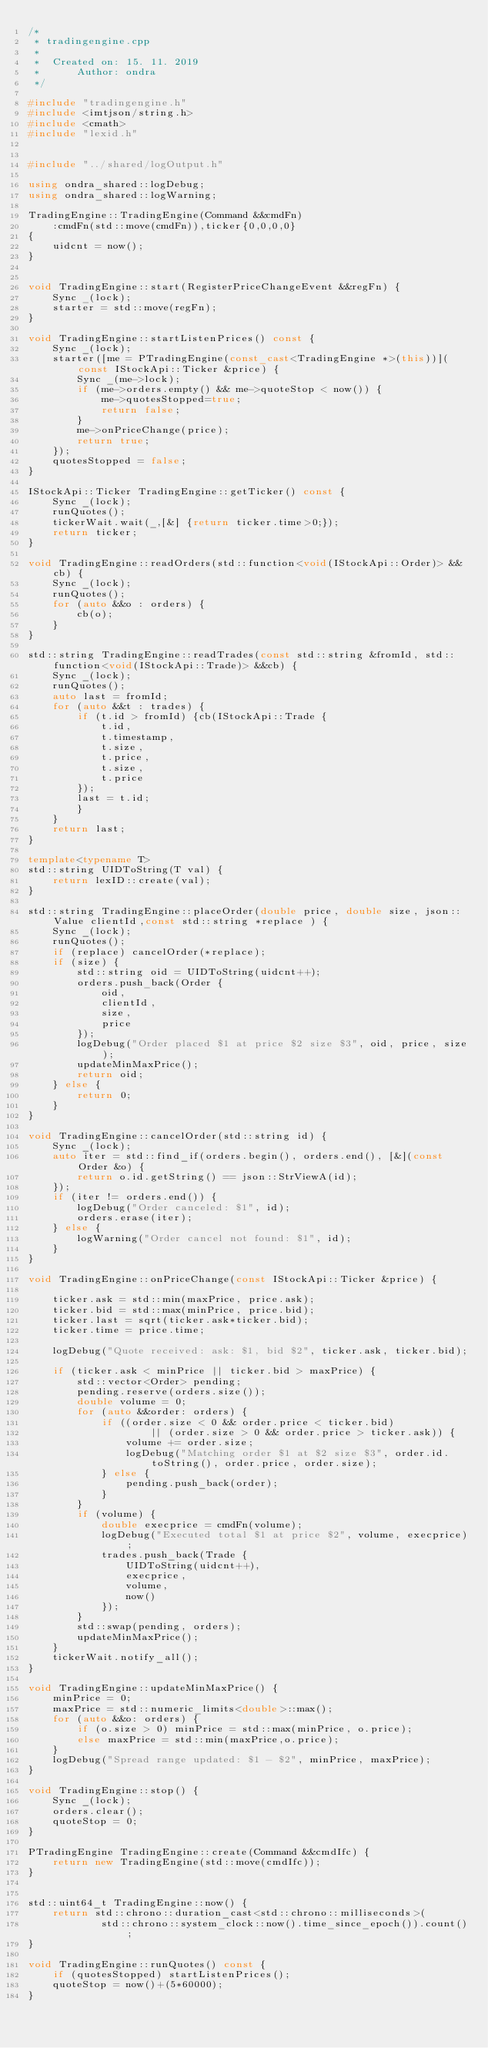<code> <loc_0><loc_0><loc_500><loc_500><_C++_>/*
 * tradingengine.cpp
 *
 *  Created on: 15. 11. 2019
 *      Author: ondra
 */

#include "tradingengine.h"
#include <imtjson/string.h>
#include <cmath>
#include "lexid.h"


#include "../shared/logOutput.h"

using ondra_shared::logDebug;
using ondra_shared::logWarning;

TradingEngine::TradingEngine(Command &&cmdFn)
	:cmdFn(std::move(cmdFn)),ticker{0,0,0,0}
{
	uidcnt = now();
}


void TradingEngine::start(RegisterPriceChangeEvent &&regFn) {
	Sync _(lock);
	starter = std::move(regFn);
}

void TradingEngine::startListenPrices() const {
	Sync _(lock);
	starter([me = PTradingEngine(const_cast<TradingEngine *>(this))](const IStockApi::Ticker &price) {
		Sync _(me->lock);
		if (me->orders.empty() && me->quoteStop < now()) {
			me->quotesStopped=true;
			return false;
		}
		me->onPriceChange(price);
		return true;
	});
	quotesStopped = false;
}

IStockApi::Ticker TradingEngine::getTicker() const {
	Sync _(lock);
	runQuotes();
	tickerWait.wait(_,[&] {return ticker.time>0;});
	return ticker;
}

void TradingEngine::readOrders(std::function<void(IStockApi::Order)> &&cb) {
	Sync _(lock);
	runQuotes();
	for (auto &&o : orders) {
		cb(o);
	}
}

std::string TradingEngine::readTrades(const std::string &fromId, std::function<void(IStockApi::Trade)> &&cb) {
	Sync _(lock);
	runQuotes();
	auto last = fromId;
	for (auto &&t : trades) {
		if (t.id > fromId) {cb(IStockApi::Trade {
			t.id,
			t.timestamp,
			t.size,
			t.price,
			t.size,
			t.price
		});
		last = t.id;
		}
	}
	return last;
}

template<typename T>
std::string UIDToString(T val) {
	return lexID::create(val);
}

std::string TradingEngine::placeOrder(double price, double size, json::Value clientId,const std::string *replace ) {
	Sync _(lock);
	runQuotes();
	if (replace) cancelOrder(*replace);
	if (size) {
		std::string oid = UIDToString(uidcnt++);
		orders.push_back(Order {
			oid,
			clientId,
			size,
			price
		});
		logDebug("Order placed $1 at price $2 size $3", oid, price, size);
		updateMinMaxPrice();
		return oid;
	} else {
		return 0;
	}
}

void TradingEngine::cancelOrder(std::string id) {
	Sync _(lock);
	auto iter = std::find_if(orders.begin(), orders.end(), [&](const Order &o) {
		return o.id.getString() == json::StrViewA(id);
	});
	if (iter != orders.end()) {
		logDebug("Order canceled: $1", id);
		orders.erase(iter);
	} else {
		logWarning("Order cancel not found: $1", id);
	}
}

void TradingEngine::onPriceChange(const IStockApi::Ticker &price) {

	ticker.ask = std::min(maxPrice, price.ask);
	ticker.bid = std::max(minPrice, price.bid);
	ticker.last = sqrt(ticker.ask*ticker.bid);
	ticker.time = price.time;

	logDebug("Quote received: ask: $1, bid $2", ticker.ask, ticker.bid);

	if (ticker.ask < minPrice || ticker.bid > maxPrice) {
		std::vector<Order> pending;
		pending.reserve(orders.size());
		double volume = 0;
		for (auto &&order: orders) {
			if ((order.size < 0 && order.price < ticker.bid)
					|| (order.size > 0 && order.price > ticker.ask)) {
				volume += order.size;
				logDebug("Matching order $1 at $2 size $3", order.id.toString(), order.price, order.size);
			} else {
				pending.push_back(order);
			}
		}
		if (volume) {
			double execprice = cmdFn(volume);
			logDebug("Executed total $1 at price $2", volume, execprice);
			trades.push_back(Trade {
				UIDToString(uidcnt++),
				execprice,
				volume,
				now()
			});
		}
		std::swap(pending, orders);
		updateMinMaxPrice();
	}
	tickerWait.notify_all();
}

void TradingEngine::updateMinMaxPrice() {
	minPrice = 0;
	maxPrice = std::numeric_limits<double>::max();
	for (auto &&o: orders) {
		if (o.size > 0) minPrice = std::max(minPrice, o.price);
		else maxPrice = std::min(maxPrice,o.price);
	}
	logDebug("Spread range updated: $1 - $2", minPrice, maxPrice);
}

void TradingEngine::stop() {
	Sync _(lock);
	orders.clear();
	quoteStop = 0;
}

PTradingEngine TradingEngine::create(Command &&cmdIfc) {
	return new TradingEngine(std::move(cmdIfc));
}


std::uint64_t TradingEngine::now() {
	return std::chrono::duration_cast<std::chrono::milliseconds>(
			std::chrono::system_clock::now().time_since_epoch()).count();
}

void TradingEngine::runQuotes() const {
	if (quotesStopped) startListenPrices();
	quoteStop = now()+(5*60000);
}
</code> 